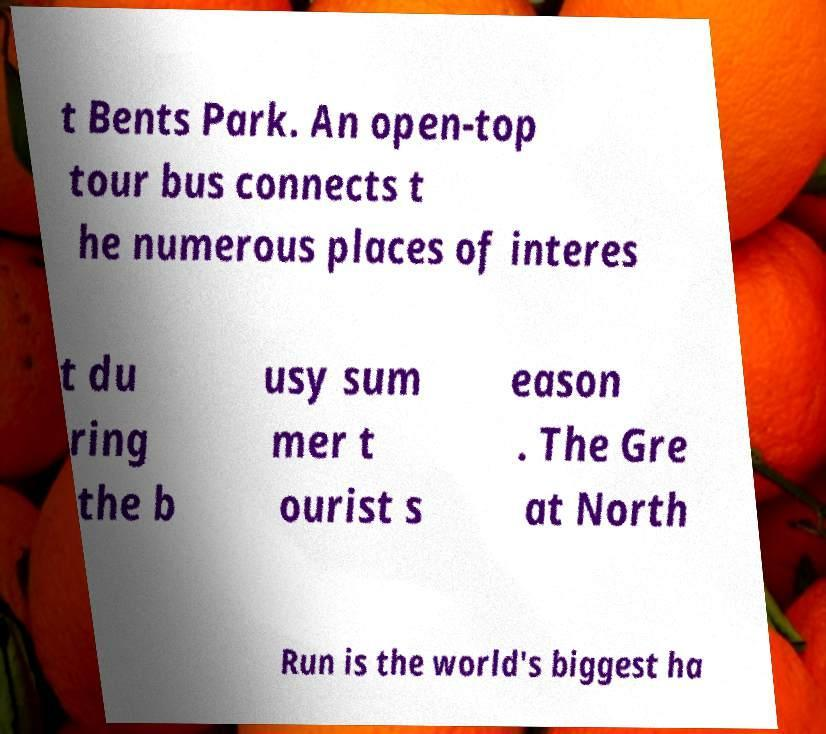Please read and relay the text visible in this image. What does it say? t Bents Park. An open-top tour bus connects t he numerous places of interes t du ring the b usy sum mer t ourist s eason . The Gre at North Run is the world's biggest ha 